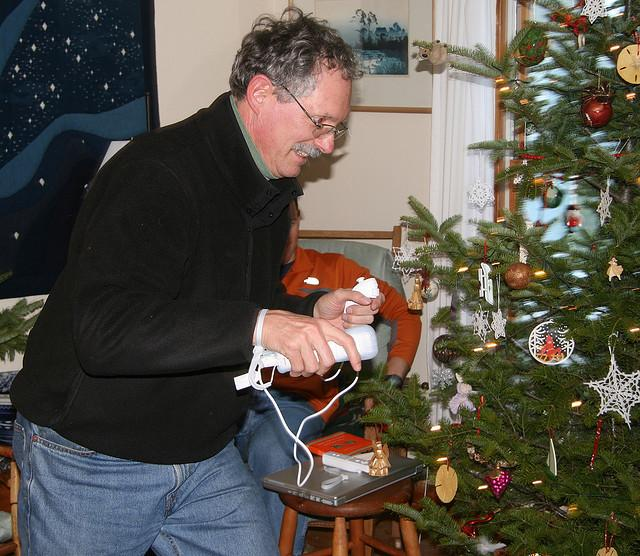What is the month depicted in the image? Please explain your reasoning. december. These types of decorated trees are usually on display during the christmas season. 